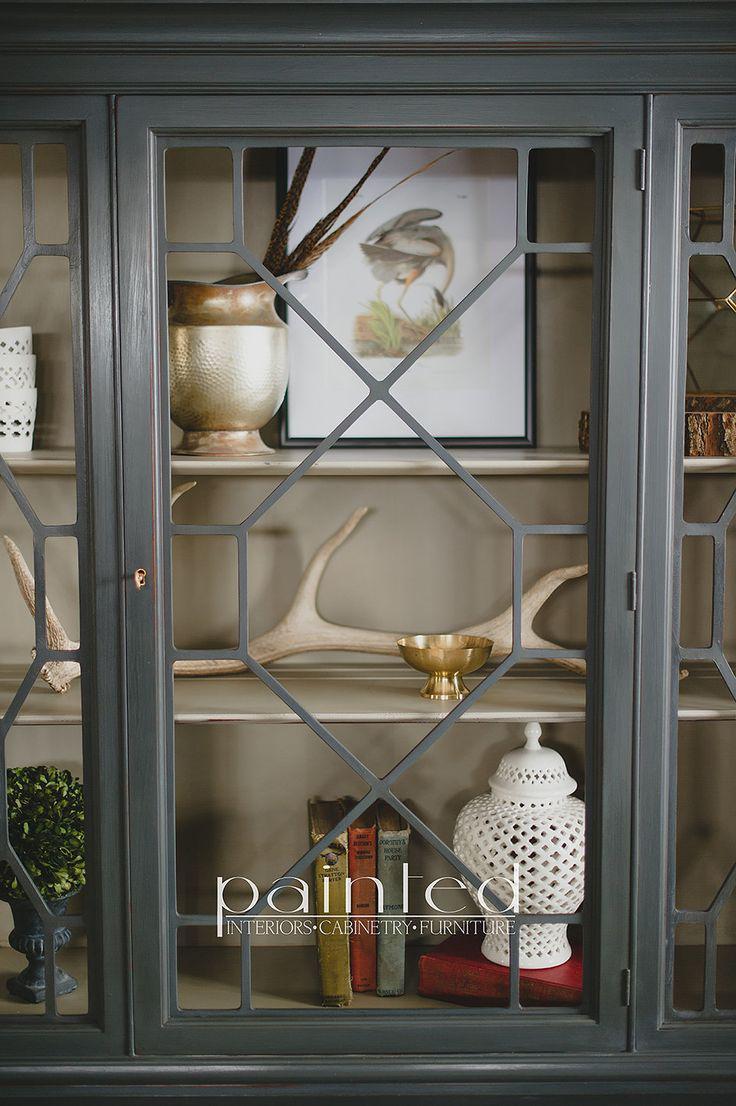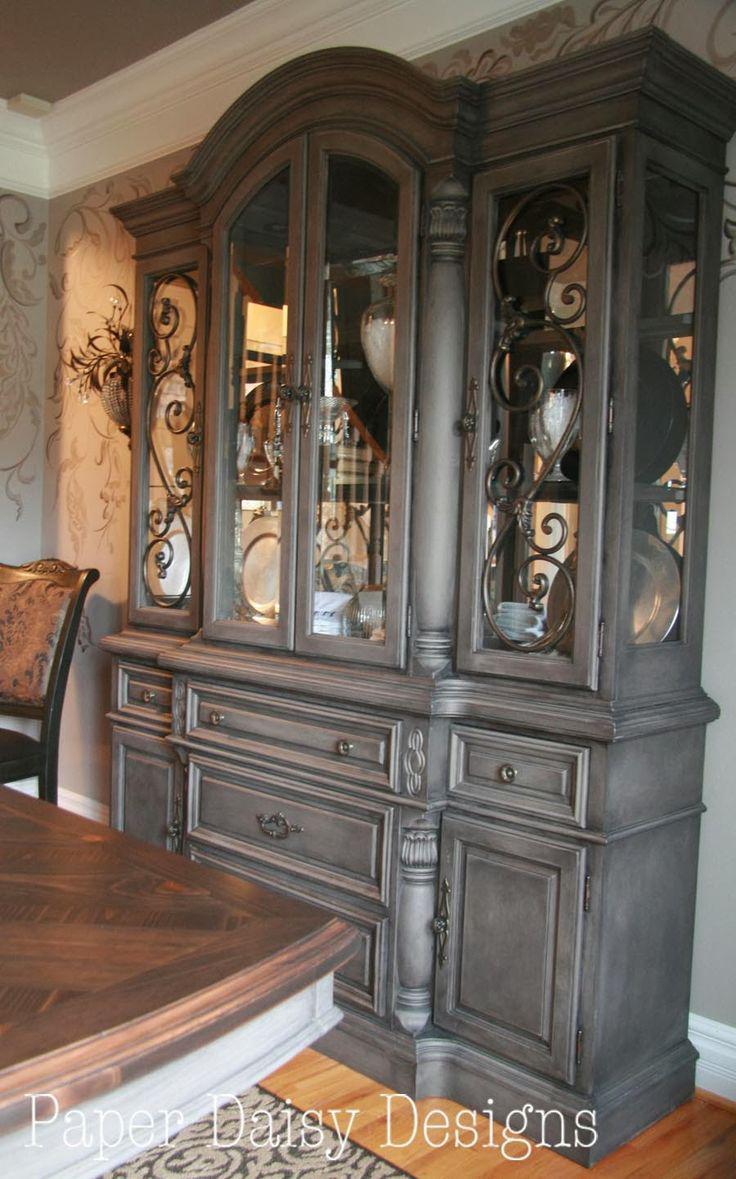The first image is the image on the left, the second image is the image on the right. For the images displayed, is the sentence "None of the cabinets are empty." factually correct? Answer yes or no. Yes. 